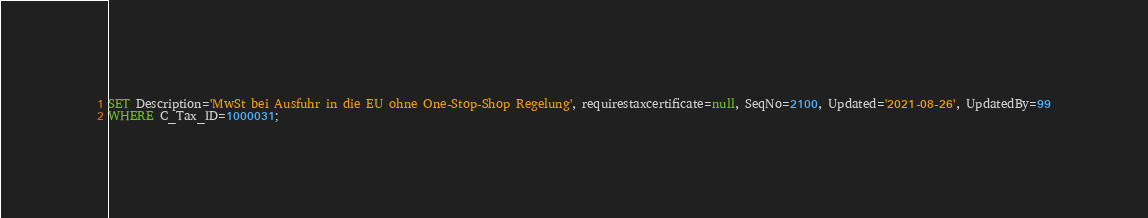<code> <loc_0><loc_0><loc_500><loc_500><_SQL_>SET Description='MwSt bei Ausfuhr in die EU ohne One-Stop-Shop Regelung', requirestaxcertificate=null, SeqNo=2100, Updated='2021-08-26', UpdatedBy=99
WHERE C_Tax_ID=1000031;
</code> 